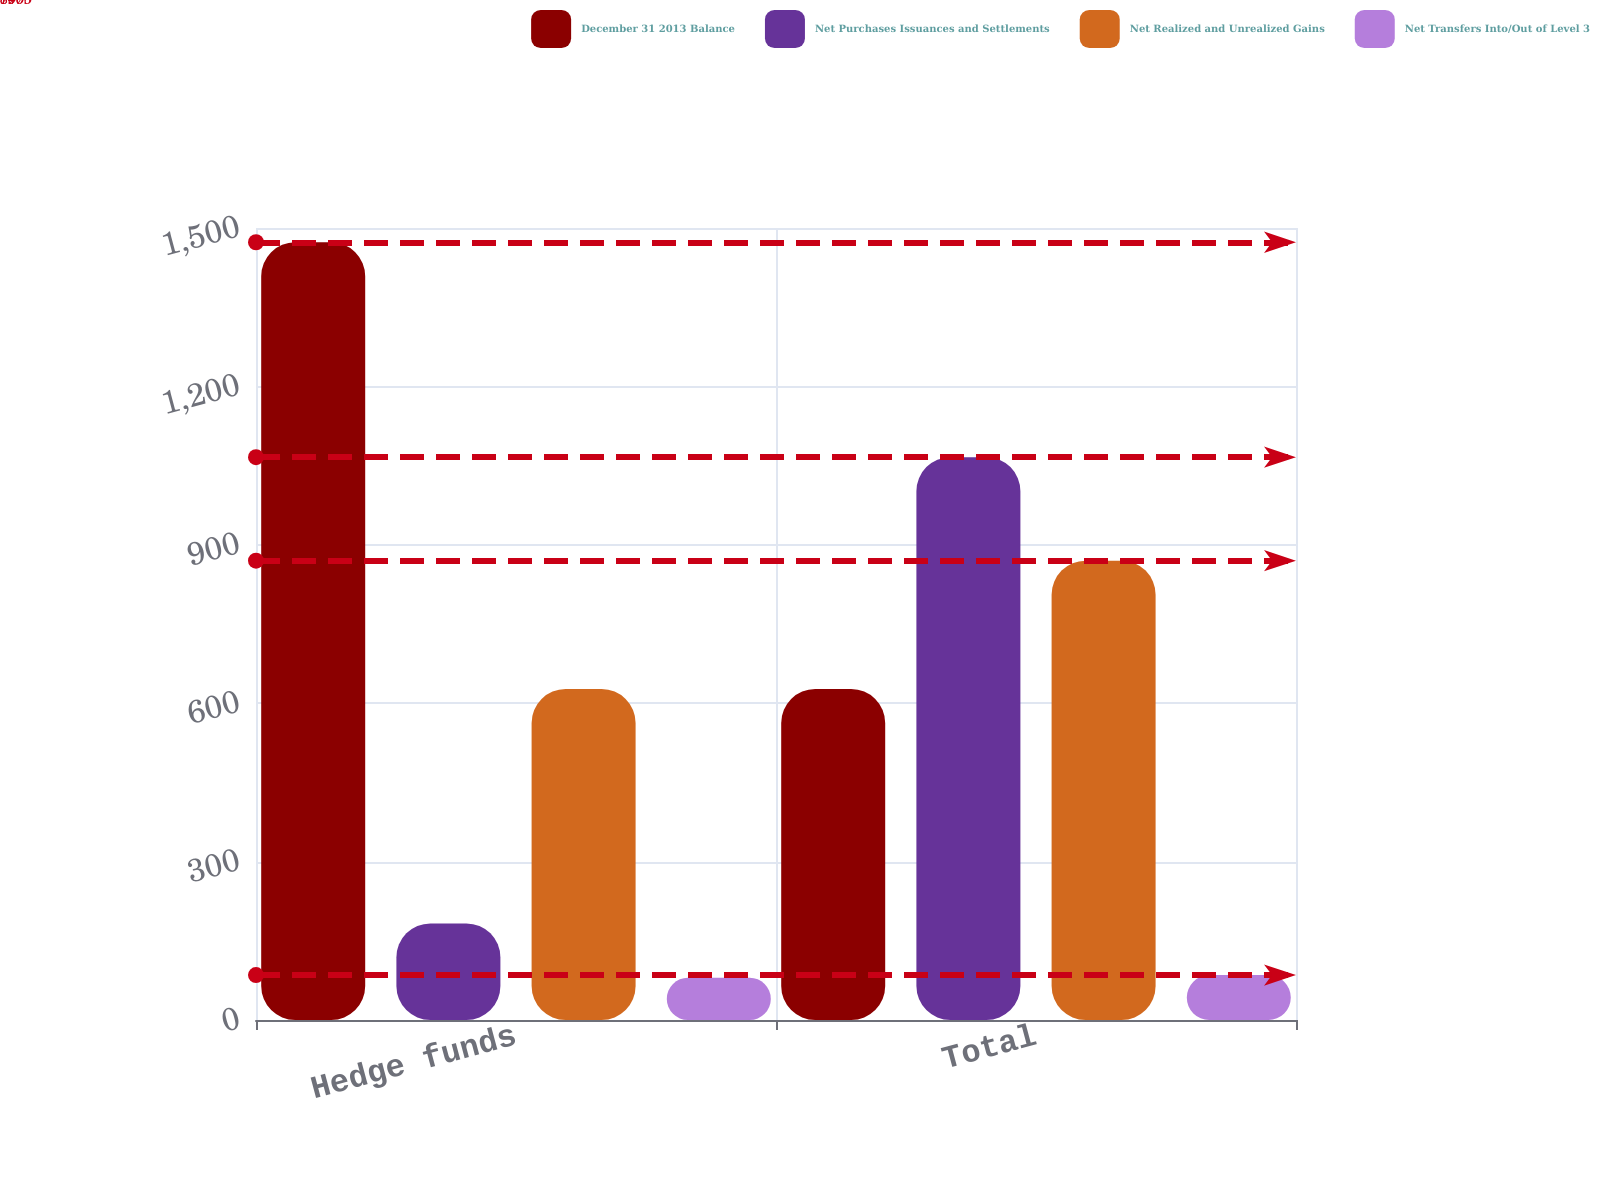Convert chart to OTSL. <chart><loc_0><loc_0><loc_500><loc_500><stacked_bar_chart><ecel><fcel>Hedge funds<fcel>Total<nl><fcel>December 31 2013 Balance<fcel>1473<fcel>627<nl><fcel>Net Purchases Issuances and Settlements<fcel>183<fcel>1066<nl><fcel>Net Realized and Unrealized Gains<fcel>627<fcel>870<nl><fcel>Net Transfers Into/Out of Level 3<fcel>80<fcel>85<nl></chart> 